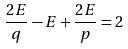<formula> <loc_0><loc_0><loc_500><loc_500>\frac { 2 E } { q } - E + \frac { 2 E } { p } = 2</formula> 